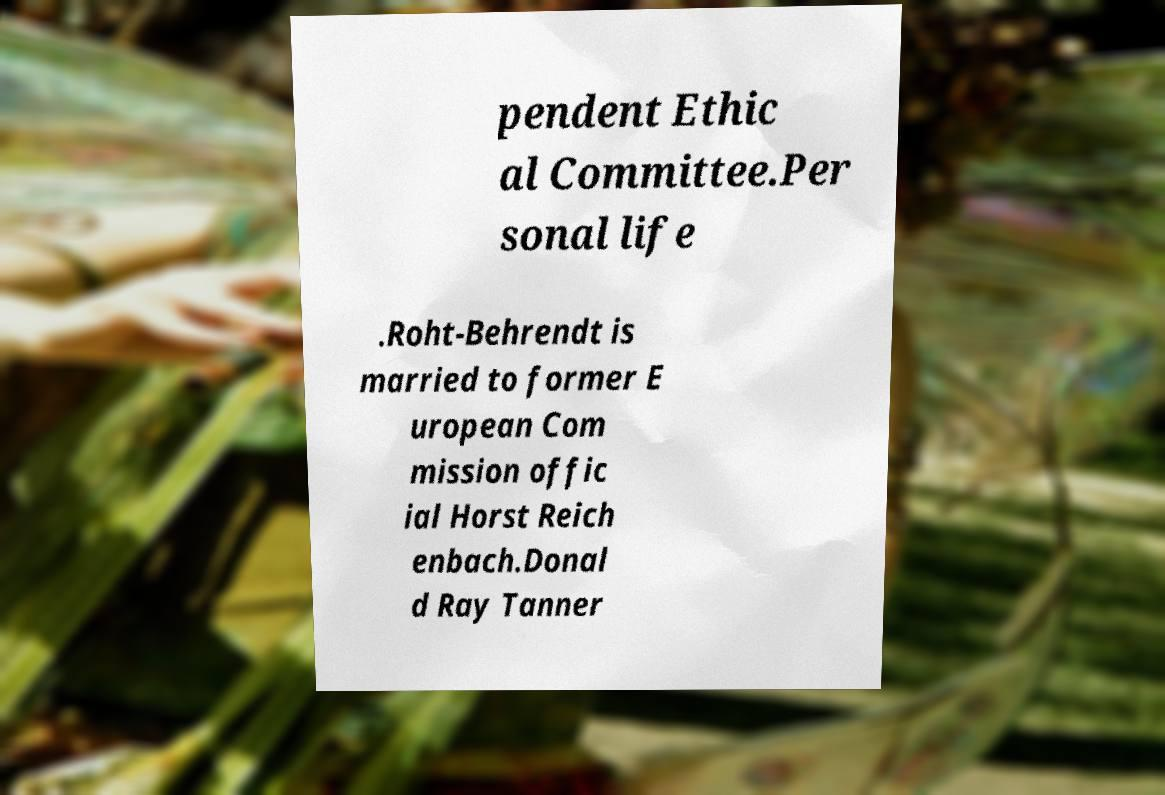Could you assist in decoding the text presented in this image and type it out clearly? pendent Ethic al Committee.Per sonal life .Roht-Behrendt is married to former E uropean Com mission offic ial Horst Reich enbach.Donal d Ray Tanner 